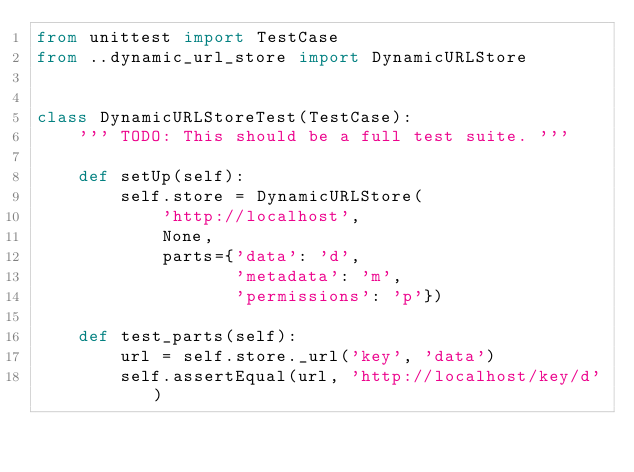Convert code to text. <code><loc_0><loc_0><loc_500><loc_500><_Python_>from unittest import TestCase
from ..dynamic_url_store import DynamicURLStore


class DynamicURLStoreTest(TestCase):
    ''' TODO: This should be a full test suite. '''

    def setUp(self):
        self.store = DynamicURLStore(
            'http://localhost',
            None,
            parts={'data': 'd',
                   'metadata': 'm',
                   'permissions': 'p'})

    def test_parts(self):
        url = self.store._url('key', 'data')
        self.assertEqual(url, 'http://localhost/key/d')
</code> 